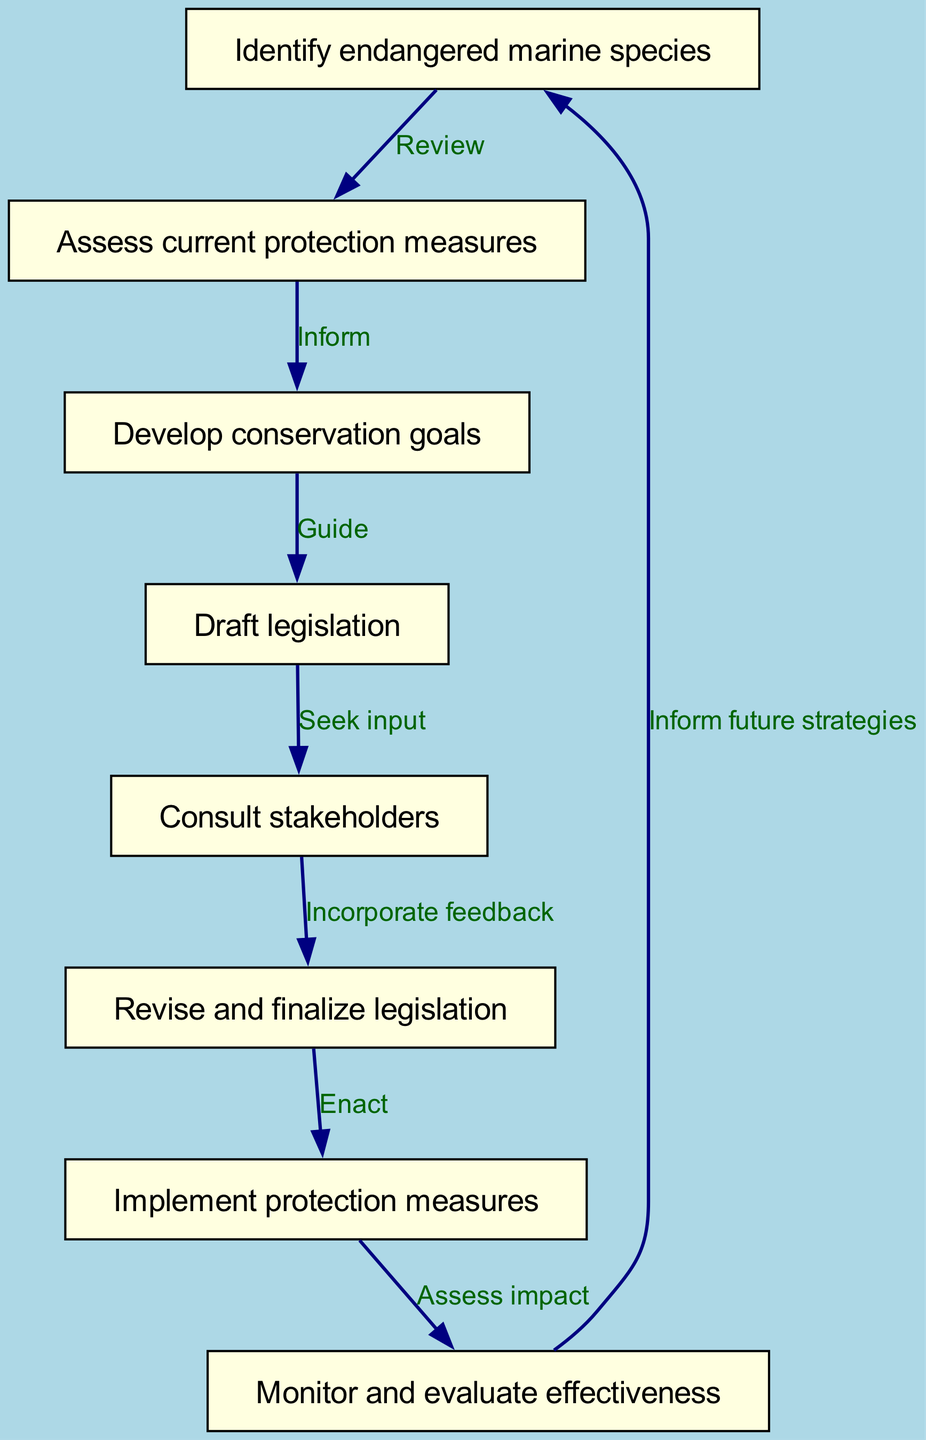What is the first step in the conservation strategy? According to the flow chart, the first node is "Identify endangered marine species," which indicates the starting point of the conservation strategy.
Answer: Identify endangered marine species How many nodes are present in the diagram? The flow chart contains 8 nodes detailing various steps in the conservation process, indicating distinct actions or stages.
Answer: 8 What action follows "Assess current protection measures"? The flow chart shows that after "Assess current protection measures," the next step is "Develop conservation goals," which is connected directly by an edge labeled "Inform."
Answer: Develop conservation goals What step occurs before "Consult stakeholders"? In the diagram, the step that occurs just before "Consult stakeholders" is "Draft legislation," which directly leads into seeking stakeholder input as the next step.
Answer: Draft legislation What is the last action in the implementation process? The final node in the flow chart is "Inform future strategies," which indicates that the monitoring and evaluation efforts feed back into informing future conservation approaches.
Answer: Inform future strategies Which nodes directly relate to the legislation drafting process? The nodes that directly relate to drafting legislation are "Develop conservation goals," which guides the drafting, and "Consult stakeholders," which seeks input on the draft.
Answer: Develop conservation goals, Consult stakeholders How do monitoring actions affect future strategies? According to the flow chart, "Monitor and evaluate effectiveness" leads back to "Identify endangered marine species," suggesting that the outcomes of monitoring are utilized to inform future conservation strategies.
Answer: Inform future strategies What is the relationship between "Implement protection measures" and "Monitor and evaluate effectiveness"? The flow chart indicates a direct relationship where "Implement protection measures" leads into "Monitor and evaluate effectiveness," signifying that the implementation is assessed for its impact.
Answer: Assess impact 